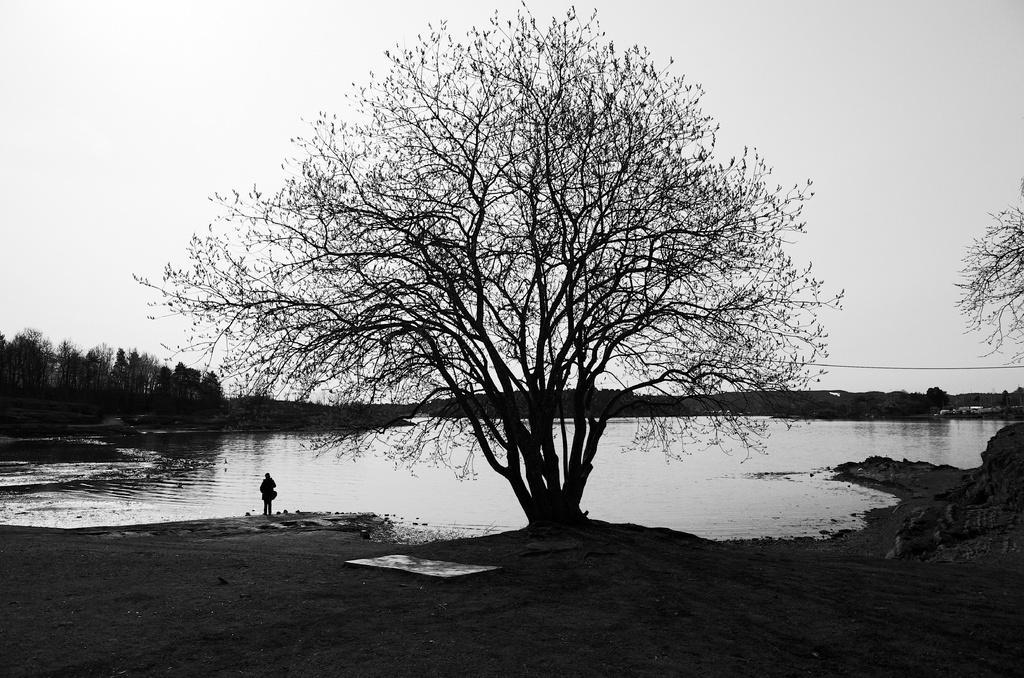In one or two sentences, can you explain what this image depicts? In this image we can see a person standing on the ground, there are few trees, water and the sky in the background. 